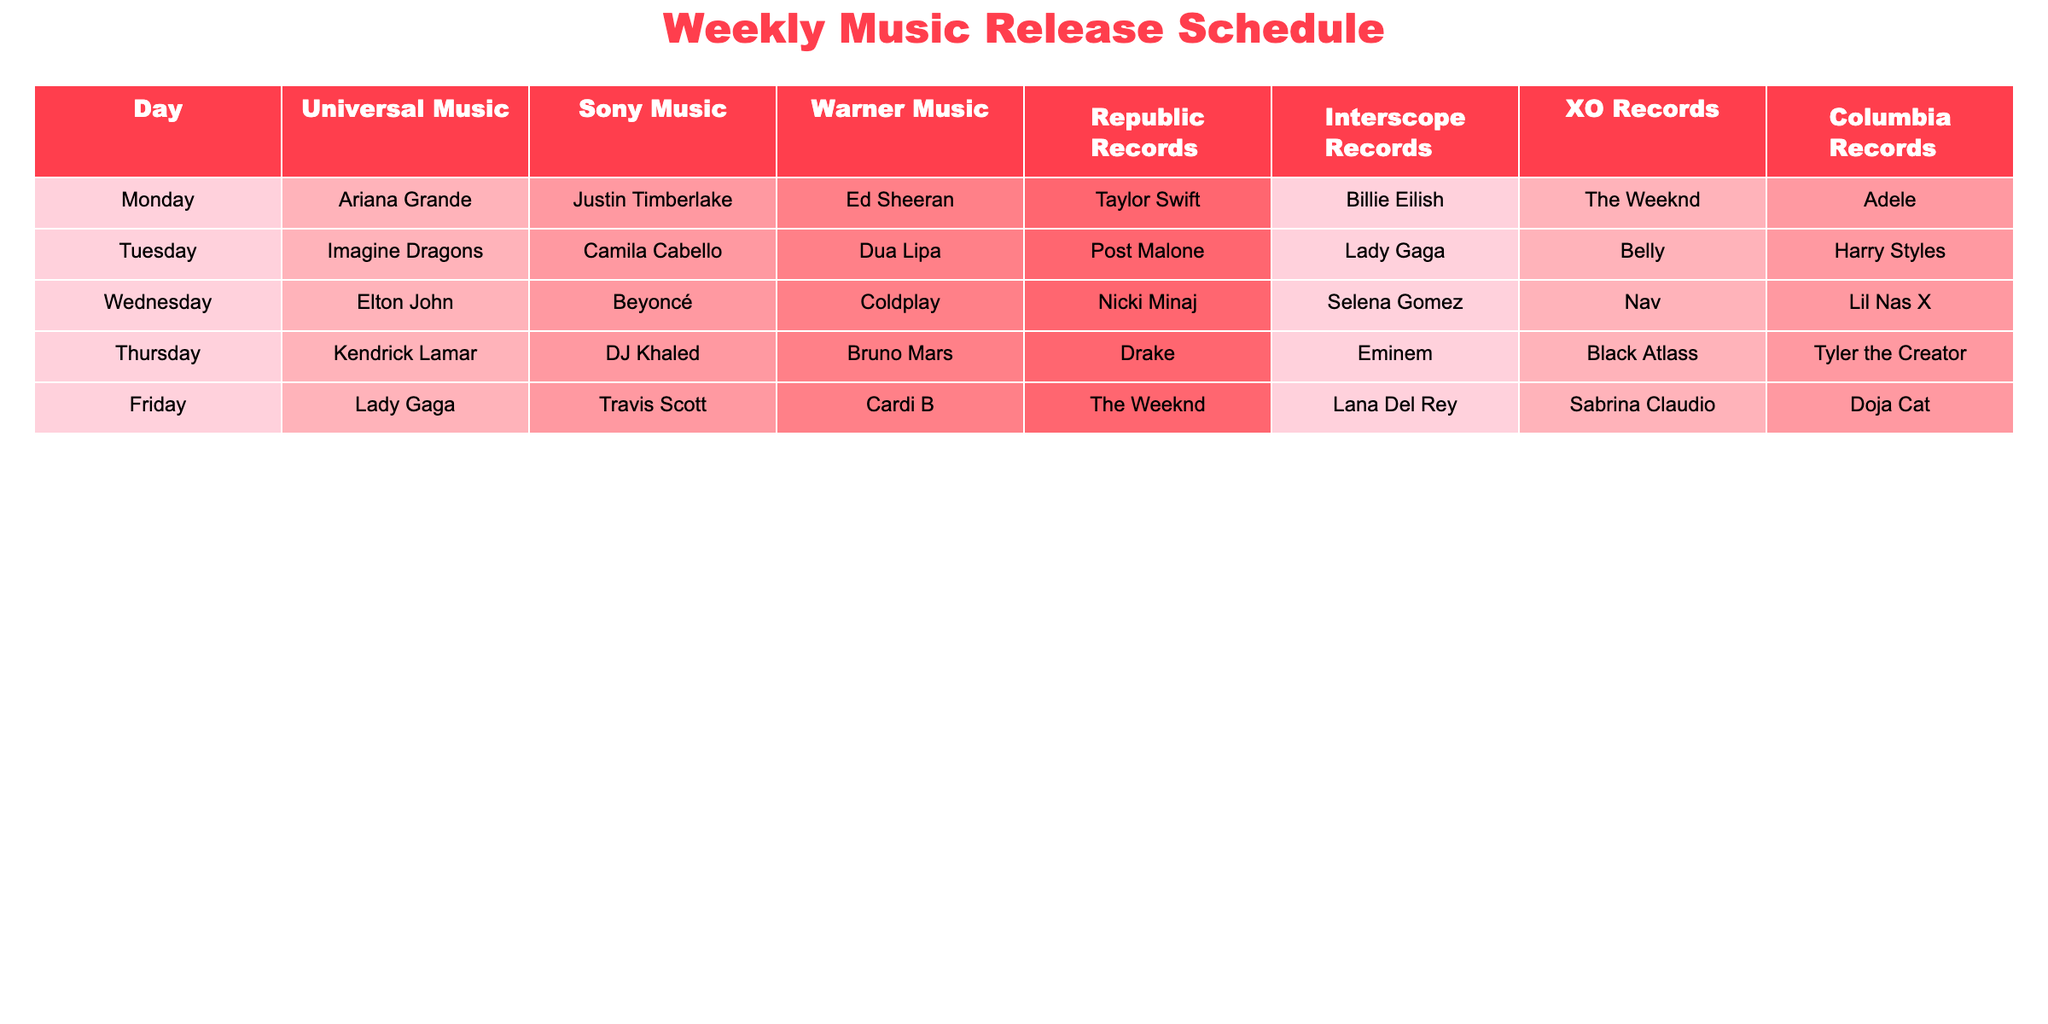What artist is scheduled to release music on Friday under Columbia Records? Looking at the table, for Friday under Columbia Records, the artist listed is Doja Cat.
Answer: Doja Cat Which artist is scheduled to release music on Tuesday under Sony Music? On Tuesday in the Sony Music column, the artist listed is Camila Cabello.
Answer: Camila Cabello Are there any artists from Republic Records releasing music on Thursday? Referring to the table, there is an artist listed under Republic Records for Thursday, which is Drake.
Answer: Yes, Drake What is the total number of artists listed for Wednesday across all record labels? By counting the artists listed for Wednesday, we have: Elton John, Beyoncé, Coldplay, Nicki Minaj, Selena Gomez, Nav, and Lil Nas X, totaling 7.
Answer: 7 Is The Weeknd scheduled for a release on more than one day? Checking the table for The Weeknd, he is only listed under Republic Records for Friday, meaning he doesn't have scheduled releases on multiple days.
Answer: No Which record label has the artist Billie Eilish scheduled for a release, and on what day? Billie Eilish is listed under Interscope Records on Monday.
Answer: Interscope Records, Monday Which day of the week has the highest number of different artists listed, and how many are there? Each day has 7 different artists listed, meaning every day has the same number of artists.
Answer: Every day, 7 On which day do both The Weeknd and Ariana Grande have scheduled music releases? Referring to the table, The Weeknd is only scheduled for Friday, while Ariana Grande is scheduled for Monday. They do not coincide on any day.
Answer: No day Which artist from XO Records is scheduled to release new music on Tuesday? For Tuesday, looking at the XO Records column, the artist is Belly.
Answer: Belly What is the earliest day in the week featuring a release by a female artist? Monday has Ariana Grande, which is an earlier day in the week featuring a female artist before any others.
Answer: Monday, Ariana Grande 